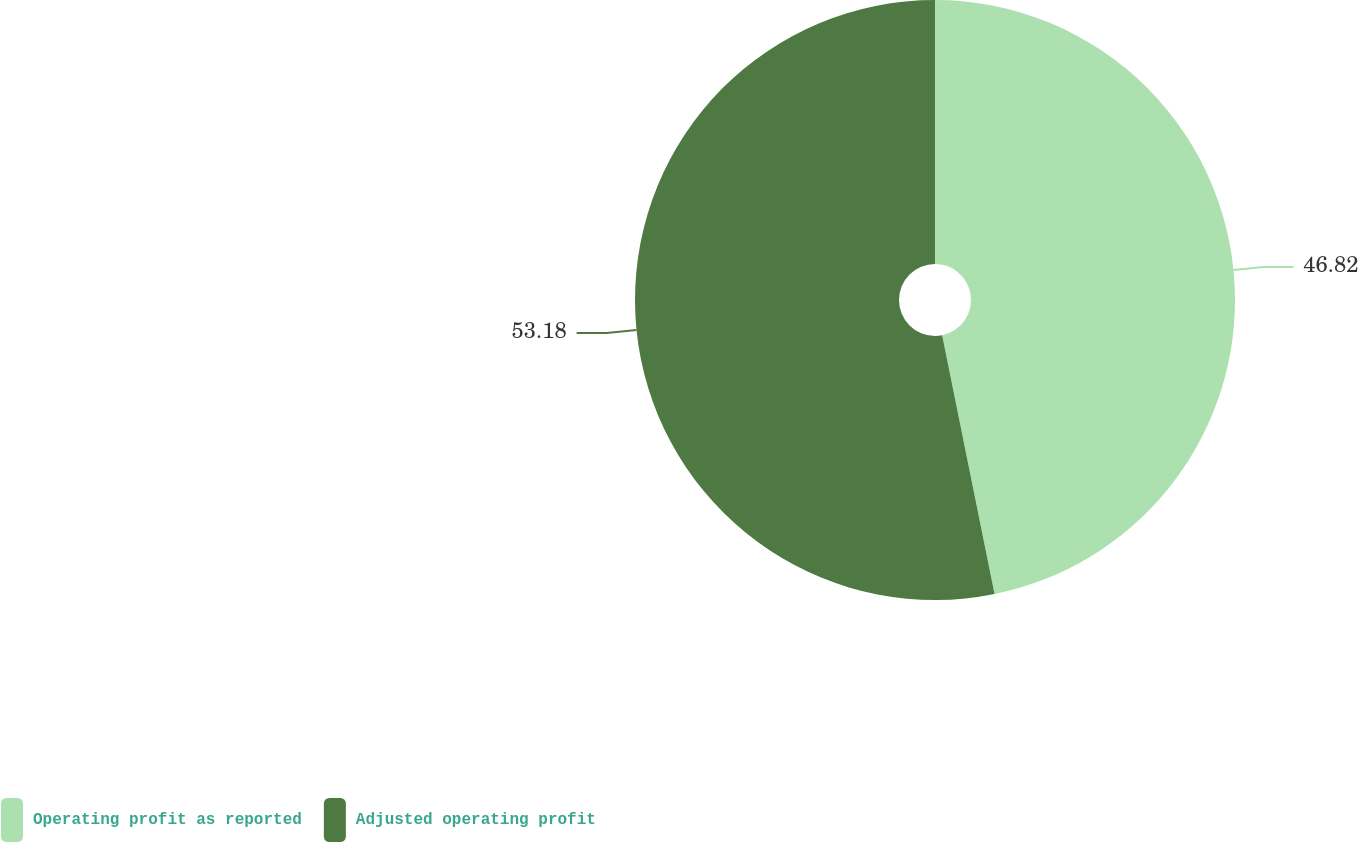Convert chart. <chart><loc_0><loc_0><loc_500><loc_500><pie_chart><fcel>Operating profit as reported<fcel>Adjusted operating profit<nl><fcel>46.82%<fcel>53.18%<nl></chart> 